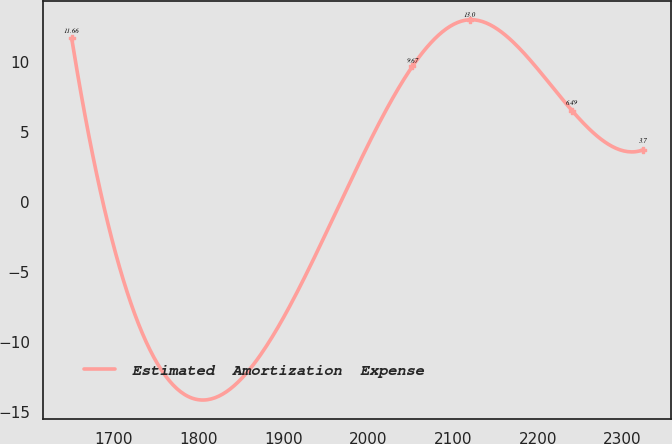<chart> <loc_0><loc_0><loc_500><loc_500><line_chart><ecel><fcel>Estimated  Amortization  Expense<nl><fcel>1650.45<fcel>11.66<nl><fcel>2052.11<fcel>9.67<nl><fcel>2119.45<fcel>13<nl><fcel>2240.57<fcel>6.49<nl><fcel>2323.8<fcel>3.7<nl></chart> 